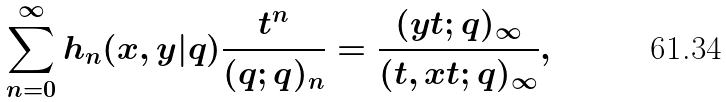Convert formula to latex. <formula><loc_0><loc_0><loc_500><loc_500>\sum _ { n = 0 } ^ { \infty } h _ { n } ( x , y | q ) \frac { t ^ { n } } { ( q ; q ) _ { n } } = \frac { ( y t ; q ) _ { \infty } } { ( t , x t ; q ) _ { \infty } } ,</formula> 